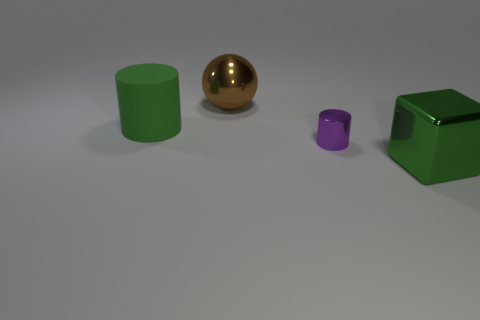Do the metal block and the large matte cylinder have the same color?
Offer a very short reply. Yes. There is a green thing on the right side of the big green cylinder; what is its size?
Offer a very short reply. Large. Are there any blue matte things of the same size as the sphere?
Your response must be concise. No. Does the rubber cylinder that is to the left of the green shiny cube have the same size as the large sphere?
Offer a terse response. Yes. What size is the shiny cylinder?
Keep it short and to the point. Small. The big shiny thing that is on the right side of the big thing behind the large green object that is behind the large cube is what color?
Give a very brief answer. Green. Is the color of the large metallic thing in front of the big green cylinder the same as the rubber object?
Ensure brevity in your answer.  Yes. What number of large things are both right of the big green cylinder and behind the shiny cylinder?
Give a very brief answer. 1. The metal object that is the same shape as the matte object is what size?
Offer a terse response. Small. There is a green thing to the left of the big object to the right of the purple metallic cylinder; how many large green objects are on the right side of it?
Keep it short and to the point. 1. 